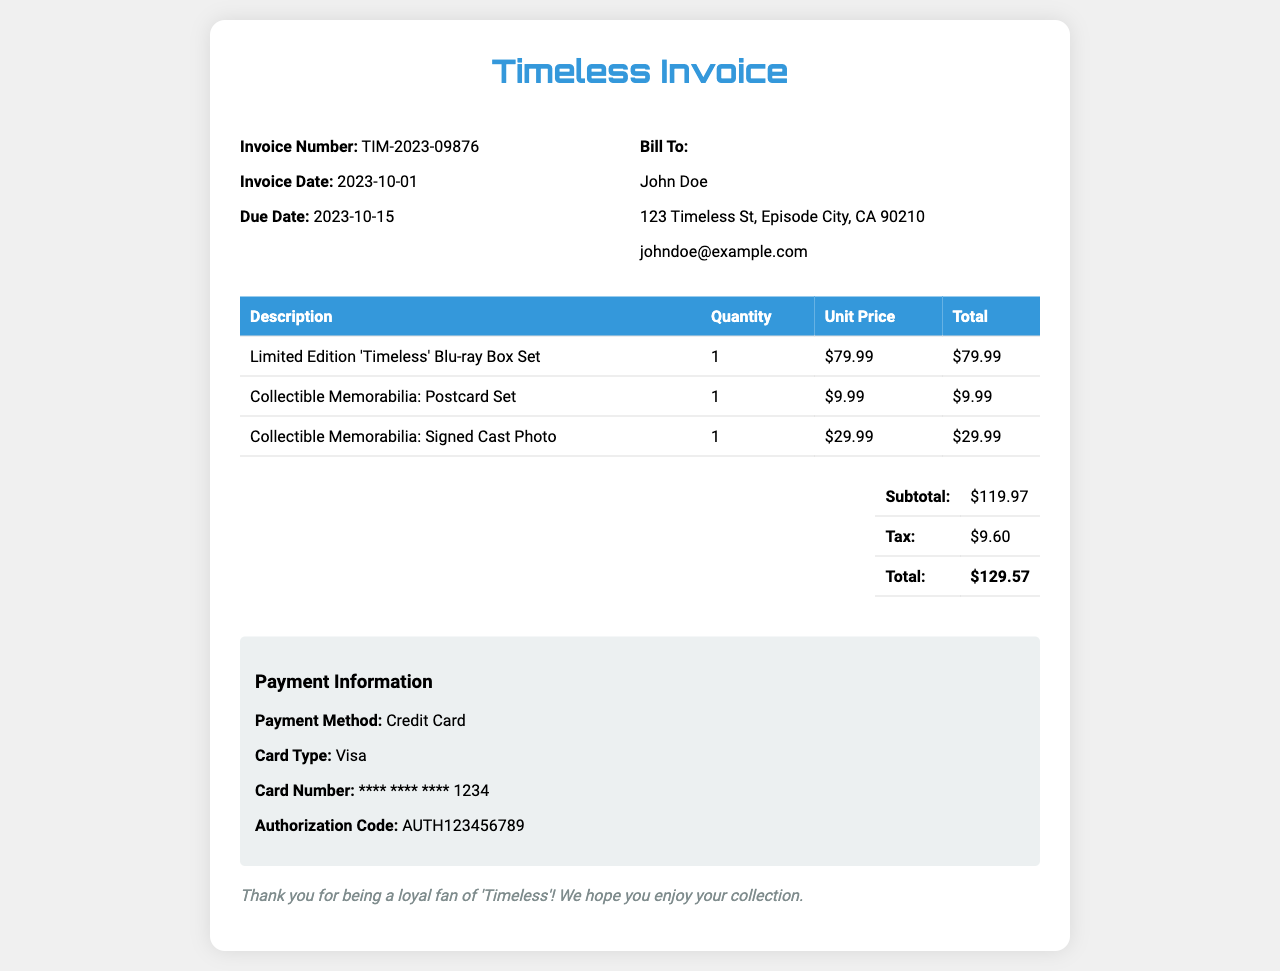What is the invoice number? The invoice number is a specific identifier contained in the document.
Answer: TIM-2023-09876 What is the total amount due? The total amount due combines the subtotal and tax to give the final value.
Answer: $129.57 Who is the bill to? The "Bill To" section specifies the name and address of the customer.
Answer: John Doe What is the due date of the invoice? This is the date by which payment must be made according to the invoice.
Answer: 2023-10-15 How many collectible memorabilia items are listed? The invoice includes a detailed listing of items, which can be summed.
Answer: 2 What is the unit price of the 'Timeless' Blu-ray Box Set? The unit price is specified next to the product description in the table.
Answer: $79.99 What type of payment method was used? This information is listed under the payment information section of the invoice.
Answer: Credit Card What is the subtotal before tax? The subtotal is the total of all items purchased before any tax is applied.
Answer: $119.97 What is the tax amount charged? The tax amount is a separate line item below the subtotal and is indicated clearly.
Answer: $9.60 